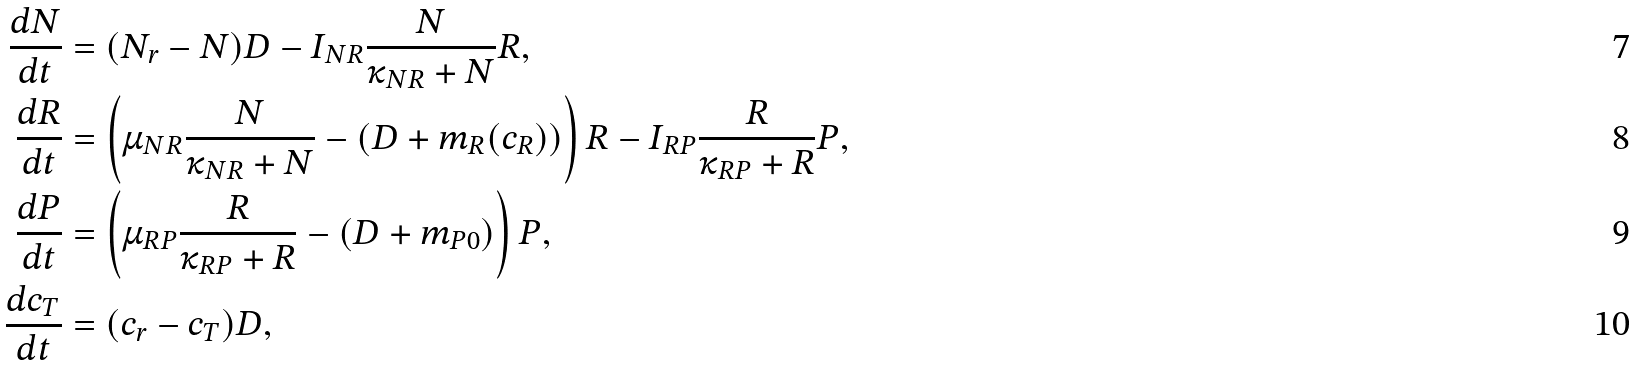Convert formula to latex. <formula><loc_0><loc_0><loc_500><loc_500>\frac { d N } { d t } & = ( N _ { r } - N ) D - I _ { N R } \frac { N } { \kappa _ { N R } + N } R , \\ \frac { d R } { d t } & = \left ( \mu _ { N R } \frac { N } { \kappa _ { N R } + N } - ( D + m _ { R } ( c _ { R } ) ) \right ) R - I _ { R P } \frac { R } { \kappa _ { R P } + R } P , \\ \frac { d P } { d t } & = \left ( \mu _ { R P } \frac { R } { \kappa _ { R P } + R } - ( D + m _ { P 0 } ) \right ) P , \\ \frac { d c _ { T } } { d t } & = ( c _ { r } - c _ { T } ) D ,</formula> 